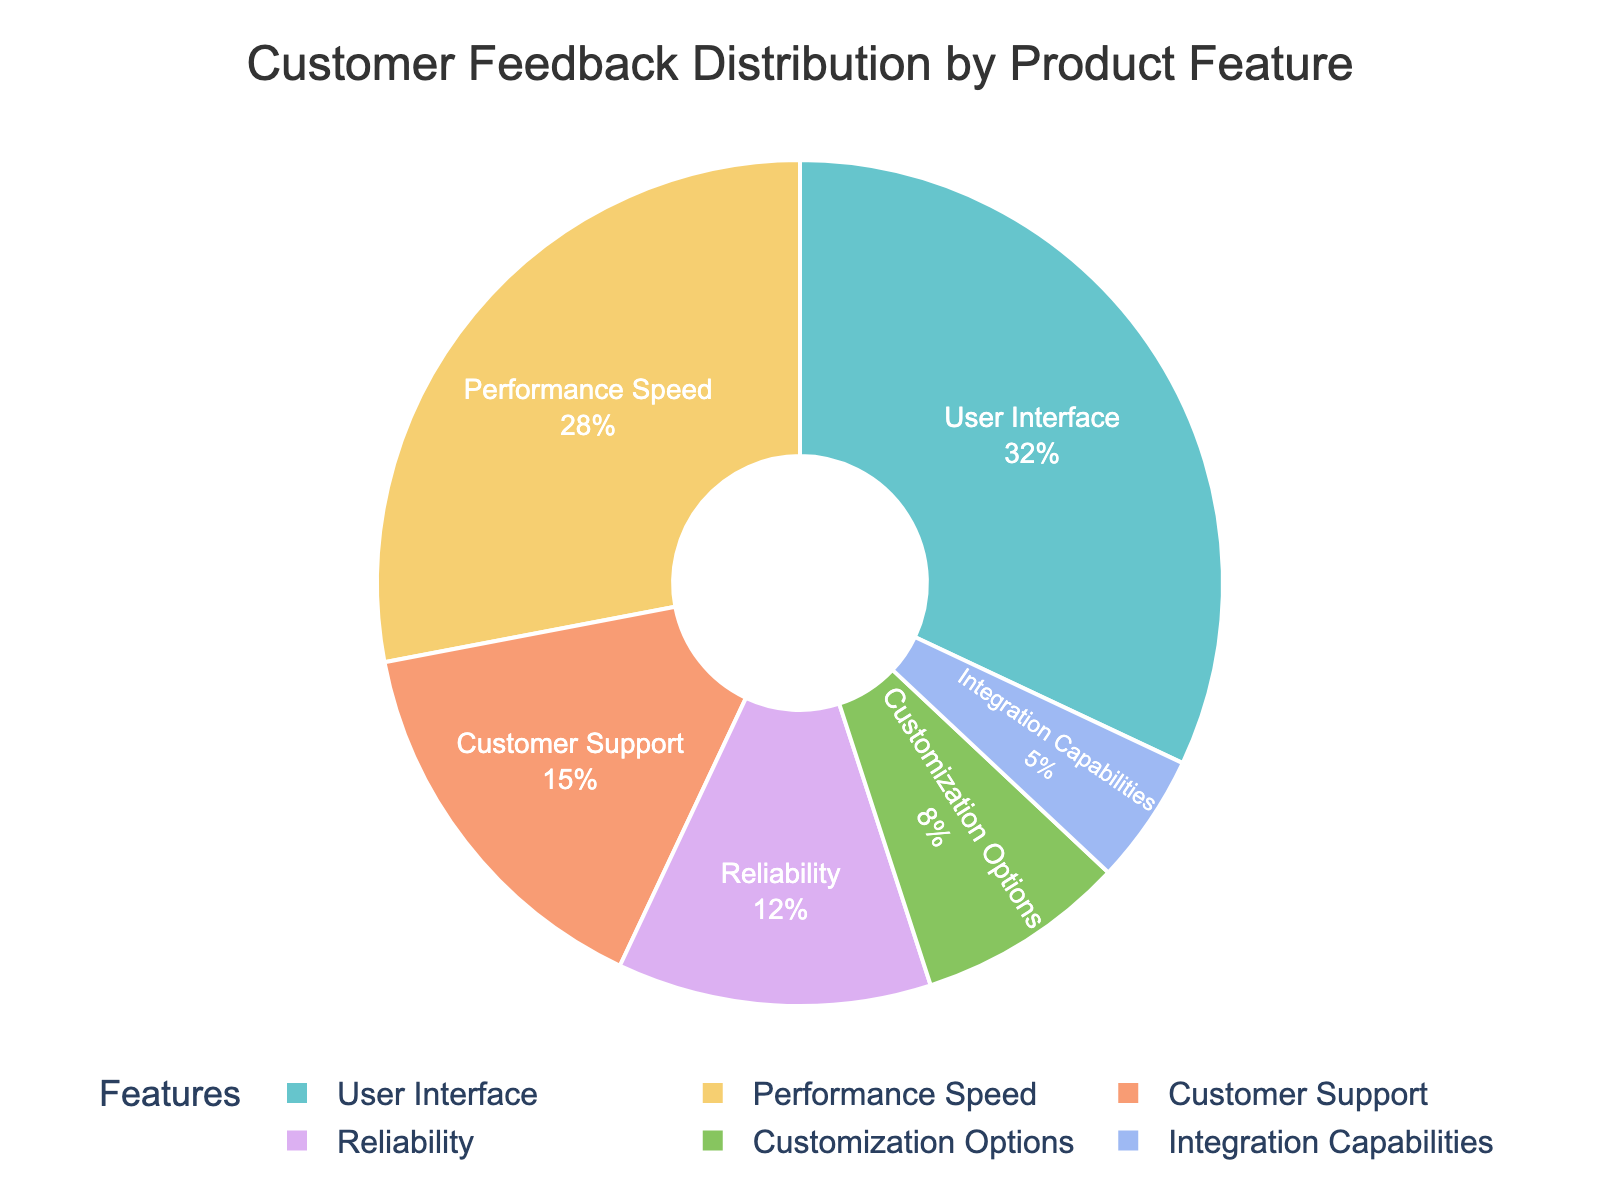Which feature has the highest satisfaction percentage? The feature with the highest satisfaction percentage can be identified by looking at the largest segment in the pie chart. The "User Interface" segment is the largest.
Answer: User Interface Which feature has the lowest satisfaction percentage? The feature with the lowest satisfaction percentage is represented by the smallest segment in the pie chart. The "Integration Capabilities" segment is the smallest.
Answer: Integration Capabilities What is the combined satisfaction percentage for Customer Support and Reliability? First, look at the percentages for "Customer Support" (15%) and "Reliability" (12%). Then add them together: 15% + 12% = 27%.
Answer: 27% Is the satisfaction percentage of Performance Speed greater than that of Customization Options? Compare the satisfaction percentages of "Performance Speed" (28%) and "Customization Options" (8%). Since 28% is greater than 8%, the satisfaction percentage of Performance Speed is indeed greater.
Answer: Yes Which features together account for more than 50% of the customer satisfaction? Identify the features and their percentages: "User Interface" (32%) and "Performance Speed" (28%). Sum them up: 32% + 28% = 60%. The combination of these two features exceeds 50%.
Answer: User Interface and Performance Speed How much larger is the satisfaction percentage for User Interface compared to Reliability? Determine the satisfaction percentages for "User Interface" (32%) and "Reliability" (12%). Find the difference: 32% - 12% = 20%.
Answer: 20% What is the average satisfaction percentage for all features? Add the satisfaction percentages of all features: 32% + 28% + 15% + 12% + 8% + 5% = 100%. Since there are 6 features, divide by 6: 100% / 6 ≈ 16.67%.
Answer: 16.67% Are the combined satisfaction percentages of Customization Options and Integration Capabilities less than that of Customer Support? First, sum up the satisfaction percentages for "Customization Options" (8%) and "Integration Capabilities" (5%): 8% + 5% = 13%. Compare this to "Customer Support" (15%). Since 13% is less than 15%, the combined percentages are less.
Answer: Yes 